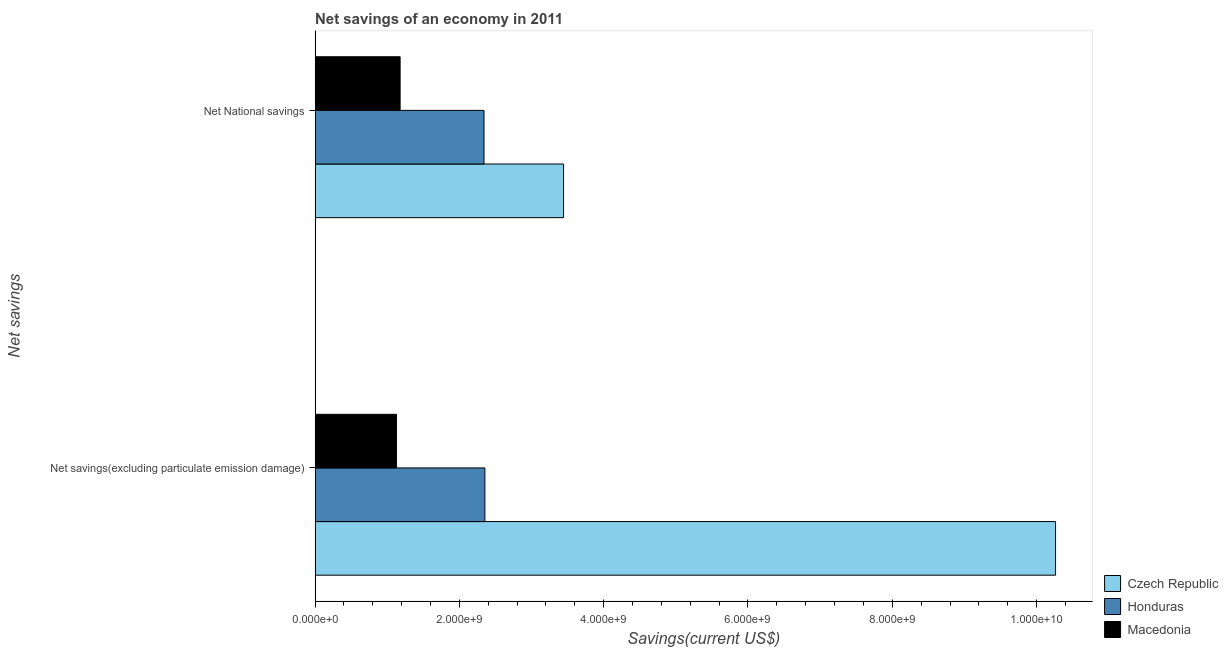How many different coloured bars are there?
Your answer should be very brief. 3. How many groups of bars are there?
Ensure brevity in your answer.  2. How many bars are there on the 1st tick from the top?
Keep it short and to the point. 3. What is the label of the 1st group of bars from the top?
Your response must be concise. Net National savings. What is the net savings(excluding particulate emission damage) in Macedonia?
Provide a succinct answer. 1.13e+09. Across all countries, what is the maximum net savings(excluding particulate emission damage)?
Offer a very short reply. 1.03e+1. Across all countries, what is the minimum net savings(excluding particulate emission damage)?
Give a very brief answer. 1.13e+09. In which country was the net national savings maximum?
Provide a short and direct response. Czech Republic. In which country was the net national savings minimum?
Your answer should be very brief. Macedonia. What is the total net savings(excluding particulate emission damage) in the graph?
Ensure brevity in your answer.  1.37e+1. What is the difference between the net savings(excluding particulate emission damage) in Macedonia and that in Czech Republic?
Provide a succinct answer. -9.14e+09. What is the difference between the net savings(excluding particulate emission damage) in Honduras and the net national savings in Macedonia?
Provide a short and direct response. 1.17e+09. What is the average net savings(excluding particulate emission damage) per country?
Give a very brief answer. 4.58e+09. What is the difference between the net savings(excluding particulate emission damage) and net national savings in Honduras?
Provide a short and direct response. 1.21e+07. What is the ratio of the net national savings in Honduras to that in Czech Republic?
Provide a succinct answer. 0.68. What does the 3rd bar from the top in Net National savings represents?
Ensure brevity in your answer.  Czech Republic. What does the 1st bar from the bottom in Net savings(excluding particulate emission damage) represents?
Your answer should be very brief. Czech Republic. How many bars are there?
Provide a succinct answer. 6. Are all the bars in the graph horizontal?
Provide a succinct answer. Yes. Does the graph contain any zero values?
Provide a succinct answer. No. Does the graph contain grids?
Offer a very short reply. No. Where does the legend appear in the graph?
Provide a short and direct response. Bottom right. How many legend labels are there?
Make the answer very short. 3. What is the title of the graph?
Your answer should be very brief. Net savings of an economy in 2011. Does "Estonia" appear as one of the legend labels in the graph?
Your answer should be very brief. No. What is the label or title of the X-axis?
Offer a very short reply. Savings(current US$). What is the label or title of the Y-axis?
Provide a succinct answer. Net savings. What is the Savings(current US$) of Czech Republic in Net savings(excluding particulate emission damage)?
Provide a short and direct response. 1.03e+1. What is the Savings(current US$) of Honduras in Net savings(excluding particulate emission damage)?
Ensure brevity in your answer.  2.35e+09. What is the Savings(current US$) in Macedonia in Net savings(excluding particulate emission damage)?
Provide a succinct answer. 1.13e+09. What is the Savings(current US$) of Czech Republic in Net National savings?
Provide a short and direct response. 3.44e+09. What is the Savings(current US$) of Honduras in Net National savings?
Ensure brevity in your answer.  2.34e+09. What is the Savings(current US$) of Macedonia in Net National savings?
Give a very brief answer. 1.18e+09. Across all Net savings, what is the maximum Savings(current US$) in Czech Republic?
Make the answer very short. 1.03e+1. Across all Net savings, what is the maximum Savings(current US$) of Honduras?
Offer a terse response. 2.35e+09. Across all Net savings, what is the maximum Savings(current US$) in Macedonia?
Your answer should be compact. 1.18e+09. Across all Net savings, what is the minimum Savings(current US$) of Czech Republic?
Provide a short and direct response. 3.44e+09. Across all Net savings, what is the minimum Savings(current US$) of Honduras?
Offer a very short reply. 2.34e+09. Across all Net savings, what is the minimum Savings(current US$) in Macedonia?
Your answer should be compact. 1.13e+09. What is the total Savings(current US$) of Czech Republic in the graph?
Make the answer very short. 1.37e+1. What is the total Savings(current US$) in Honduras in the graph?
Offer a very short reply. 4.69e+09. What is the total Savings(current US$) of Macedonia in the graph?
Provide a short and direct response. 2.31e+09. What is the difference between the Savings(current US$) of Czech Republic in Net savings(excluding particulate emission damage) and that in Net National savings?
Provide a short and direct response. 6.82e+09. What is the difference between the Savings(current US$) of Honduras in Net savings(excluding particulate emission damage) and that in Net National savings?
Ensure brevity in your answer.  1.21e+07. What is the difference between the Savings(current US$) of Macedonia in Net savings(excluding particulate emission damage) and that in Net National savings?
Keep it short and to the point. -5.06e+07. What is the difference between the Savings(current US$) in Czech Republic in Net savings(excluding particulate emission damage) and the Savings(current US$) in Honduras in Net National savings?
Provide a succinct answer. 7.92e+09. What is the difference between the Savings(current US$) in Czech Republic in Net savings(excluding particulate emission damage) and the Savings(current US$) in Macedonia in Net National savings?
Make the answer very short. 9.08e+09. What is the difference between the Savings(current US$) of Honduras in Net savings(excluding particulate emission damage) and the Savings(current US$) of Macedonia in Net National savings?
Your answer should be very brief. 1.17e+09. What is the average Savings(current US$) in Czech Republic per Net savings?
Ensure brevity in your answer.  6.85e+09. What is the average Savings(current US$) of Honduras per Net savings?
Your answer should be very brief. 2.35e+09. What is the average Savings(current US$) in Macedonia per Net savings?
Your answer should be compact. 1.15e+09. What is the difference between the Savings(current US$) of Czech Republic and Savings(current US$) of Honduras in Net savings(excluding particulate emission damage)?
Your response must be concise. 7.91e+09. What is the difference between the Savings(current US$) of Czech Republic and Savings(current US$) of Macedonia in Net savings(excluding particulate emission damage)?
Your answer should be compact. 9.14e+09. What is the difference between the Savings(current US$) in Honduras and Savings(current US$) in Macedonia in Net savings(excluding particulate emission damage)?
Provide a succinct answer. 1.23e+09. What is the difference between the Savings(current US$) of Czech Republic and Savings(current US$) of Honduras in Net National savings?
Offer a very short reply. 1.10e+09. What is the difference between the Savings(current US$) of Czech Republic and Savings(current US$) of Macedonia in Net National savings?
Your answer should be compact. 2.27e+09. What is the difference between the Savings(current US$) of Honduras and Savings(current US$) of Macedonia in Net National savings?
Keep it short and to the point. 1.16e+09. What is the ratio of the Savings(current US$) in Czech Republic in Net savings(excluding particulate emission damage) to that in Net National savings?
Keep it short and to the point. 2.98. What is the difference between the highest and the second highest Savings(current US$) of Czech Republic?
Provide a succinct answer. 6.82e+09. What is the difference between the highest and the second highest Savings(current US$) in Honduras?
Ensure brevity in your answer.  1.21e+07. What is the difference between the highest and the second highest Savings(current US$) of Macedonia?
Provide a short and direct response. 5.06e+07. What is the difference between the highest and the lowest Savings(current US$) in Czech Republic?
Give a very brief answer. 6.82e+09. What is the difference between the highest and the lowest Savings(current US$) of Honduras?
Your answer should be very brief. 1.21e+07. What is the difference between the highest and the lowest Savings(current US$) in Macedonia?
Offer a very short reply. 5.06e+07. 